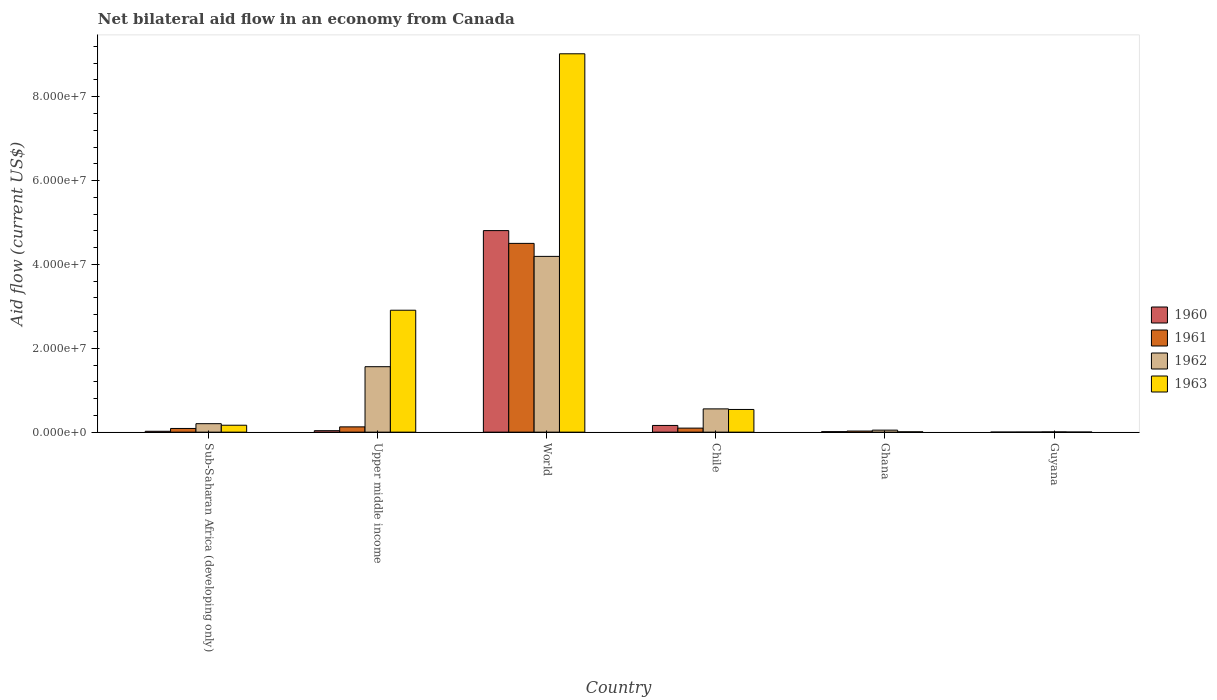How many different coloured bars are there?
Keep it short and to the point. 4. How many groups of bars are there?
Keep it short and to the point. 6. How many bars are there on the 5th tick from the right?
Your response must be concise. 4. What is the label of the 1st group of bars from the left?
Provide a short and direct response. Sub-Saharan Africa (developing only). What is the net bilateral aid flow in 1962 in World?
Offer a very short reply. 4.19e+07. Across all countries, what is the maximum net bilateral aid flow in 1962?
Your response must be concise. 4.19e+07. In which country was the net bilateral aid flow in 1963 maximum?
Give a very brief answer. World. In which country was the net bilateral aid flow in 1963 minimum?
Give a very brief answer. Guyana. What is the total net bilateral aid flow in 1962 in the graph?
Give a very brief answer. 6.56e+07. What is the difference between the net bilateral aid flow in 1960 in Chile and that in World?
Provide a succinct answer. -4.65e+07. What is the difference between the net bilateral aid flow in 1962 in Ghana and the net bilateral aid flow in 1960 in Upper middle income?
Offer a terse response. 1.30e+05. What is the average net bilateral aid flow in 1961 per country?
Your answer should be compact. 8.07e+06. What is the difference between the net bilateral aid flow of/in 1962 and net bilateral aid flow of/in 1963 in Upper middle income?
Your response must be concise. -1.35e+07. In how many countries, is the net bilateral aid flow in 1961 greater than 64000000 US$?
Offer a terse response. 0. What is the ratio of the net bilateral aid flow in 1963 in Ghana to that in Sub-Saharan Africa (developing only)?
Offer a very short reply. 0.05. What is the difference between the highest and the second highest net bilateral aid flow in 1962?
Provide a short and direct response. 2.63e+07. What is the difference between the highest and the lowest net bilateral aid flow in 1960?
Your answer should be compact. 4.81e+07. In how many countries, is the net bilateral aid flow in 1962 greater than the average net bilateral aid flow in 1962 taken over all countries?
Offer a terse response. 2. Is the sum of the net bilateral aid flow in 1963 in Sub-Saharan Africa (developing only) and Upper middle income greater than the maximum net bilateral aid flow in 1960 across all countries?
Give a very brief answer. No. Is it the case that in every country, the sum of the net bilateral aid flow in 1960 and net bilateral aid flow in 1961 is greater than the sum of net bilateral aid flow in 1962 and net bilateral aid flow in 1963?
Provide a succinct answer. No. How many bars are there?
Your answer should be compact. 24. How many countries are there in the graph?
Your answer should be compact. 6. Are the values on the major ticks of Y-axis written in scientific E-notation?
Your response must be concise. Yes. Does the graph contain any zero values?
Provide a succinct answer. No. Does the graph contain grids?
Provide a succinct answer. No. Where does the legend appear in the graph?
Your answer should be compact. Center right. How many legend labels are there?
Provide a succinct answer. 4. How are the legend labels stacked?
Give a very brief answer. Vertical. What is the title of the graph?
Make the answer very short. Net bilateral aid flow in an economy from Canada. What is the label or title of the X-axis?
Offer a terse response. Country. What is the label or title of the Y-axis?
Your response must be concise. Aid flow (current US$). What is the Aid flow (current US$) of 1961 in Sub-Saharan Africa (developing only)?
Provide a short and direct response. 8.80e+05. What is the Aid flow (current US$) of 1962 in Sub-Saharan Africa (developing only)?
Offer a terse response. 2.02e+06. What is the Aid flow (current US$) of 1963 in Sub-Saharan Africa (developing only)?
Keep it short and to the point. 1.65e+06. What is the Aid flow (current US$) of 1961 in Upper middle income?
Keep it short and to the point. 1.26e+06. What is the Aid flow (current US$) of 1962 in Upper middle income?
Provide a succinct answer. 1.56e+07. What is the Aid flow (current US$) in 1963 in Upper middle income?
Make the answer very short. 2.91e+07. What is the Aid flow (current US$) in 1960 in World?
Your answer should be compact. 4.81e+07. What is the Aid flow (current US$) of 1961 in World?
Your answer should be compact. 4.50e+07. What is the Aid flow (current US$) in 1962 in World?
Offer a very short reply. 4.19e+07. What is the Aid flow (current US$) in 1963 in World?
Make the answer very short. 9.02e+07. What is the Aid flow (current US$) of 1960 in Chile?
Provide a short and direct response. 1.60e+06. What is the Aid flow (current US$) of 1961 in Chile?
Your answer should be very brief. 9.60e+05. What is the Aid flow (current US$) of 1962 in Chile?
Offer a terse response. 5.55e+06. What is the Aid flow (current US$) of 1963 in Chile?
Ensure brevity in your answer.  5.41e+06. What is the Aid flow (current US$) in 1960 in Ghana?
Your answer should be compact. 1.20e+05. What is the Aid flow (current US$) of 1961 in Ghana?
Give a very brief answer. 2.60e+05. What is the Aid flow (current US$) of 1962 in Ghana?
Give a very brief answer. 4.80e+05. What is the Aid flow (current US$) of 1961 in Guyana?
Provide a short and direct response. 2.00e+04. Across all countries, what is the maximum Aid flow (current US$) in 1960?
Offer a terse response. 4.81e+07. Across all countries, what is the maximum Aid flow (current US$) of 1961?
Ensure brevity in your answer.  4.50e+07. Across all countries, what is the maximum Aid flow (current US$) of 1962?
Provide a short and direct response. 4.19e+07. Across all countries, what is the maximum Aid flow (current US$) in 1963?
Your response must be concise. 9.02e+07. Across all countries, what is the minimum Aid flow (current US$) in 1960?
Offer a very short reply. 10000. Across all countries, what is the minimum Aid flow (current US$) in 1961?
Give a very brief answer. 2.00e+04. Across all countries, what is the minimum Aid flow (current US$) in 1962?
Provide a short and direct response. 6.00e+04. Across all countries, what is the minimum Aid flow (current US$) in 1963?
Provide a short and direct response. 2.00e+04. What is the total Aid flow (current US$) of 1960 in the graph?
Your answer should be very brief. 5.04e+07. What is the total Aid flow (current US$) in 1961 in the graph?
Give a very brief answer. 4.84e+07. What is the total Aid flow (current US$) in 1962 in the graph?
Your answer should be very brief. 6.56e+07. What is the total Aid flow (current US$) of 1963 in the graph?
Give a very brief answer. 1.26e+08. What is the difference between the Aid flow (current US$) of 1961 in Sub-Saharan Africa (developing only) and that in Upper middle income?
Your answer should be very brief. -3.80e+05. What is the difference between the Aid flow (current US$) in 1962 in Sub-Saharan Africa (developing only) and that in Upper middle income?
Your response must be concise. -1.36e+07. What is the difference between the Aid flow (current US$) of 1963 in Sub-Saharan Africa (developing only) and that in Upper middle income?
Offer a very short reply. -2.74e+07. What is the difference between the Aid flow (current US$) in 1960 in Sub-Saharan Africa (developing only) and that in World?
Make the answer very short. -4.79e+07. What is the difference between the Aid flow (current US$) in 1961 in Sub-Saharan Africa (developing only) and that in World?
Offer a very short reply. -4.41e+07. What is the difference between the Aid flow (current US$) of 1962 in Sub-Saharan Africa (developing only) and that in World?
Your answer should be compact. -3.99e+07. What is the difference between the Aid flow (current US$) in 1963 in Sub-Saharan Africa (developing only) and that in World?
Offer a terse response. -8.86e+07. What is the difference between the Aid flow (current US$) of 1960 in Sub-Saharan Africa (developing only) and that in Chile?
Your answer should be very brief. -1.39e+06. What is the difference between the Aid flow (current US$) in 1962 in Sub-Saharan Africa (developing only) and that in Chile?
Your answer should be compact. -3.53e+06. What is the difference between the Aid flow (current US$) of 1963 in Sub-Saharan Africa (developing only) and that in Chile?
Provide a short and direct response. -3.76e+06. What is the difference between the Aid flow (current US$) in 1961 in Sub-Saharan Africa (developing only) and that in Ghana?
Ensure brevity in your answer.  6.20e+05. What is the difference between the Aid flow (current US$) of 1962 in Sub-Saharan Africa (developing only) and that in Ghana?
Offer a very short reply. 1.54e+06. What is the difference between the Aid flow (current US$) of 1963 in Sub-Saharan Africa (developing only) and that in Ghana?
Give a very brief answer. 1.57e+06. What is the difference between the Aid flow (current US$) in 1961 in Sub-Saharan Africa (developing only) and that in Guyana?
Your answer should be compact. 8.60e+05. What is the difference between the Aid flow (current US$) in 1962 in Sub-Saharan Africa (developing only) and that in Guyana?
Give a very brief answer. 1.96e+06. What is the difference between the Aid flow (current US$) of 1963 in Sub-Saharan Africa (developing only) and that in Guyana?
Keep it short and to the point. 1.63e+06. What is the difference between the Aid flow (current US$) in 1960 in Upper middle income and that in World?
Give a very brief answer. -4.77e+07. What is the difference between the Aid flow (current US$) in 1961 in Upper middle income and that in World?
Provide a short and direct response. -4.38e+07. What is the difference between the Aid flow (current US$) of 1962 in Upper middle income and that in World?
Provide a short and direct response. -2.63e+07. What is the difference between the Aid flow (current US$) of 1963 in Upper middle income and that in World?
Your answer should be very brief. -6.12e+07. What is the difference between the Aid flow (current US$) of 1960 in Upper middle income and that in Chile?
Your answer should be very brief. -1.25e+06. What is the difference between the Aid flow (current US$) of 1962 in Upper middle income and that in Chile?
Provide a succinct answer. 1.01e+07. What is the difference between the Aid flow (current US$) in 1963 in Upper middle income and that in Chile?
Provide a short and direct response. 2.37e+07. What is the difference between the Aid flow (current US$) in 1961 in Upper middle income and that in Ghana?
Your answer should be compact. 1.00e+06. What is the difference between the Aid flow (current US$) of 1962 in Upper middle income and that in Ghana?
Give a very brief answer. 1.51e+07. What is the difference between the Aid flow (current US$) of 1963 in Upper middle income and that in Ghana?
Make the answer very short. 2.90e+07. What is the difference between the Aid flow (current US$) in 1961 in Upper middle income and that in Guyana?
Your answer should be compact. 1.24e+06. What is the difference between the Aid flow (current US$) of 1962 in Upper middle income and that in Guyana?
Your response must be concise. 1.56e+07. What is the difference between the Aid flow (current US$) of 1963 in Upper middle income and that in Guyana?
Offer a terse response. 2.91e+07. What is the difference between the Aid flow (current US$) in 1960 in World and that in Chile?
Provide a succinct answer. 4.65e+07. What is the difference between the Aid flow (current US$) in 1961 in World and that in Chile?
Ensure brevity in your answer.  4.41e+07. What is the difference between the Aid flow (current US$) of 1962 in World and that in Chile?
Provide a short and direct response. 3.64e+07. What is the difference between the Aid flow (current US$) in 1963 in World and that in Chile?
Ensure brevity in your answer.  8.48e+07. What is the difference between the Aid flow (current US$) of 1960 in World and that in Ghana?
Make the answer very short. 4.80e+07. What is the difference between the Aid flow (current US$) in 1961 in World and that in Ghana?
Your response must be concise. 4.48e+07. What is the difference between the Aid flow (current US$) of 1962 in World and that in Ghana?
Your response must be concise. 4.14e+07. What is the difference between the Aid flow (current US$) in 1963 in World and that in Ghana?
Your answer should be very brief. 9.02e+07. What is the difference between the Aid flow (current US$) of 1960 in World and that in Guyana?
Make the answer very short. 4.81e+07. What is the difference between the Aid flow (current US$) of 1961 in World and that in Guyana?
Ensure brevity in your answer.  4.50e+07. What is the difference between the Aid flow (current US$) of 1962 in World and that in Guyana?
Your response must be concise. 4.19e+07. What is the difference between the Aid flow (current US$) of 1963 in World and that in Guyana?
Keep it short and to the point. 9.02e+07. What is the difference between the Aid flow (current US$) in 1960 in Chile and that in Ghana?
Offer a terse response. 1.48e+06. What is the difference between the Aid flow (current US$) of 1961 in Chile and that in Ghana?
Keep it short and to the point. 7.00e+05. What is the difference between the Aid flow (current US$) of 1962 in Chile and that in Ghana?
Make the answer very short. 5.07e+06. What is the difference between the Aid flow (current US$) in 1963 in Chile and that in Ghana?
Your response must be concise. 5.33e+06. What is the difference between the Aid flow (current US$) in 1960 in Chile and that in Guyana?
Offer a terse response. 1.59e+06. What is the difference between the Aid flow (current US$) of 1961 in Chile and that in Guyana?
Offer a very short reply. 9.40e+05. What is the difference between the Aid flow (current US$) of 1962 in Chile and that in Guyana?
Offer a very short reply. 5.49e+06. What is the difference between the Aid flow (current US$) in 1963 in Chile and that in Guyana?
Offer a very short reply. 5.39e+06. What is the difference between the Aid flow (current US$) of 1960 in Ghana and that in Guyana?
Offer a terse response. 1.10e+05. What is the difference between the Aid flow (current US$) of 1961 in Ghana and that in Guyana?
Ensure brevity in your answer.  2.40e+05. What is the difference between the Aid flow (current US$) in 1962 in Ghana and that in Guyana?
Offer a terse response. 4.20e+05. What is the difference between the Aid flow (current US$) in 1960 in Sub-Saharan Africa (developing only) and the Aid flow (current US$) in 1961 in Upper middle income?
Keep it short and to the point. -1.05e+06. What is the difference between the Aid flow (current US$) of 1960 in Sub-Saharan Africa (developing only) and the Aid flow (current US$) of 1962 in Upper middle income?
Offer a very short reply. -1.54e+07. What is the difference between the Aid flow (current US$) in 1960 in Sub-Saharan Africa (developing only) and the Aid flow (current US$) in 1963 in Upper middle income?
Offer a terse response. -2.89e+07. What is the difference between the Aid flow (current US$) of 1961 in Sub-Saharan Africa (developing only) and the Aid flow (current US$) of 1962 in Upper middle income?
Your response must be concise. -1.47e+07. What is the difference between the Aid flow (current US$) in 1961 in Sub-Saharan Africa (developing only) and the Aid flow (current US$) in 1963 in Upper middle income?
Your response must be concise. -2.82e+07. What is the difference between the Aid flow (current US$) in 1962 in Sub-Saharan Africa (developing only) and the Aid flow (current US$) in 1963 in Upper middle income?
Give a very brief answer. -2.71e+07. What is the difference between the Aid flow (current US$) of 1960 in Sub-Saharan Africa (developing only) and the Aid flow (current US$) of 1961 in World?
Provide a short and direct response. -4.48e+07. What is the difference between the Aid flow (current US$) in 1960 in Sub-Saharan Africa (developing only) and the Aid flow (current US$) in 1962 in World?
Make the answer very short. -4.17e+07. What is the difference between the Aid flow (current US$) of 1960 in Sub-Saharan Africa (developing only) and the Aid flow (current US$) of 1963 in World?
Your answer should be compact. -9.00e+07. What is the difference between the Aid flow (current US$) of 1961 in Sub-Saharan Africa (developing only) and the Aid flow (current US$) of 1962 in World?
Provide a succinct answer. -4.10e+07. What is the difference between the Aid flow (current US$) in 1961 in Sub-Saharan Africa (developing only) and the Aid flow (current US$) in 1963 in World?
Offer a terse response. -8.94e+07. What is the difference between the Aid flow (current US$) of 1962 in Sub-Saharan Africa (developing only) and the Aid flow (current US$) of 1963 in World?
Your answer should be very brief. -8.82e+07. What is the difference between the Aid flow (current US$) in 1960 in Sub-Saharan Africa (developing only) and the Aid flow (current US$) in 1961 in Chile?
Offer a very short reply. -7.50e+05. What is the difference between the Aid flow (current US$) in 1960 in Sub-Saharan Africa (developing only) and the Aid flow (current US$) in 1962 in Chile?
Make the answer very short. -5.34e+06. What is the difference between the Aid flow (current US$) of 1960 in Sub-Saharan Africa (developing only) and the Aid flow (current US$) of 1963 in Chile?
Provide a succinct answer. -5.20e+06. What is the difference between the Aid flow (current US$) of 1961 in Sub-Saharan Africa (developing only) and the Aid flow (current US$) of 1962 in Chile?
Provide a succinct answer. -4.67e+06. What is the difference between the Aid flow (current US$) in 1961 in Sub-Saharan Africa (developing only) and the Aid flow (current US$) in 1963 in Chile?
Offer a very short reply. -4.53e+06. What is the difference between the Aid flow (current US$) in 1962 in Sub-Saharan Africa (developing only) and the Aid flow (current US$) in 1963 in Chile?
Make the answer very short. -3.39e+06. What is the difference between the Aid flow (current US$) in 1960 in Sub-Saharan Africa (developing only) and the Aid flow (current US$) in 1961 in Ghana?
Keep it short and to the point. -5.00e+04. What is the difference between the Aid flow (current US$) in 1960 in Sub-Saharan Africa (developing only) and the Aid flow (current US$) in 1962 in Ghana?
Your answer should be compact. -2.70e+05. What is the difference between the Aid flow (current US$) of 1961 in Sub-Saharan Africa (developing only) and the Aid flow (current US$) of 1962 in Ghana?
Keep it short and to the point. 4.00e+05. What is the difference between the Aid flow (current US$) in 1961 in Sub-Saharan Africa (developing only) and the Aid flow (current US$) in 1963 in Ghana?
Provide a succinct answer. 8.00e+05. What is the difference between the Aid flow (current US$) of 1962 in Sub-Saharan Africa (developing only) and the Aid flow (current US$) of 1963 in Ghana?
Make the answer very short. 1.94e+06. What is the difference between the Aid flow (current US$) in 1960 in Sub-Saharan Africa (developing only) and the Aid flow (current US$) in 1962 in Guyana?
Offer a terse response. 1.50e+05. What is the difference between the Aid flow (current US$) in 1961 in Sub-Saharan Africa (developing only) and the Aid flow (current US$) in 1962 in Guyana?
Keep it short and to the point. 8.20e+05. What is the difference between the Aid flow (current US$) in 1961 in Sub-Saharan Africa (developing only) and the Aid flow (current US$) in 1963 in Guyana?
Provide a short and direct response. 8.60e+05. What is the difference between the Aid flow (current US$) of 1960 in Upper middle income and the Aid flow (current US$) of 1961 in World?
Your response must be concise. -4.47e+07. What is the difference between the Aid flow (current US$) in 1960 in Upper middle income and the Aid flow (current US$) in 1962 in World?
Offer a very short reply. -4.16e+07. What is the difference between the Aid flow (current US$) of 1960 in Upper middle income and the Aid flow (current US$) of 1963 in World?
Your response must be concise. -8.99e+07. What is the difference between the Aid flow (current US$) of 1961 in Upper middle income and the Aid flow (current US$) of 1962 in World?
Make the answer very short. -4.07e+07. What is the difference between the Aid flow (current US$) in 1961 in Upper middle income and the Aid flow (current US$) in 1963 in World?
Ensure brevity in your answer.  -8.90e+07. What is the difference between the Aid flow (current US$) of 1962 in Upper middle income and the Aid flow (current US$) of 1963 in World?
Offer a terse response. -7.46e+07. What is the difference between the Aid flow (current US$) in 1960 in Upper middle income and the Aid flow (current US$) in 1961 in Chile?
Your answer should be compact. -6.10e+05. What is the difference between the Aid flow (current US$) of 1960 in Upper middle income and the Aid flow (current US$) of 1962 in Chile?
Your response must be concise. -5.20e+06. What is the difference between the Aid flow (current US$) in 1960 in Upper middle income and the Aid flow (current US$) in 1963 in Chile?
Provide a succinct answer. -5.06e+06. What is the difference between the Aid flow (current US$) in 1961 in Upper middle income and the Aid flow (current US$) in 1962 in Chile?
Provide a short and direct response. -4.29e+06. What is the difference between the Aid flow (current US$) of 1961 in Upper middle income and the Aid flow (current US$) of 1963 in Chile?
Offer a very short reply. -4.15e+06. What is the difference between the Aid flow (current US$) in 1962 in Upper middle income and the Aid flow (current US$) in 1963 in Chile?
Offer a very short reply. 1.02e+07. What is the difference between the Aid flow (current US$) in 1960 in Upper middle income and the Aid flow (current US$) in 1961 in Ghana?
Keep it short and to the point. 9.00e+04. What is the difference between the Aid flow (current US$) of 1960 in Upper middle income and the Aid flow (current US$) of 1962 in Ghana?
Offer a very short reply. -1.30e+05. What is the difference between the Aid flow (current US$) of 1961 in Upper middle income and the Aid flow (current US$) of 1962 in Ghana?
Offer a very short reply. 7.80e+05. What is the difference between the Aid flow (current US$) of 1961 in Upper middle income and the Aid flow (current US$) of 1963 in Ghana?
Your response must be concise. 1.18e+06. What is the difference between the Aid flow (current US$) in 1962 in Upper middle income and the Aid flow (current US$) in 1963 in Ghana?
Your answer should be compact. 1.55e+07. What is the difference between the Aid flow (current US$) in 1960 in Upper middle income and the Aid flow (current US$) in 1962 in Guyana?
Ensure brevity in your answer.  2.90e+05. What is the difference between the Aid flow (current US$) of 1960 in Upper middle income and the Aid flow (current US$) of 1963 in Guyana?
Your response must be concise. 3.30e+05. What is the difference between the Aid flow (current US$) in 1961 in Upper middle income and the Aid flow (current US$) in 1962 in Guyana?
Your answer should be compact. 1.20e+06. What is the difference between the Aid flow (current US$) in 1961 in Upper middle income and the Aid flow (current US$) in 1963 in Guyana?
Your response must be concise. 1.24e+06. What is the difference between the Aid flow (current US$) of 1962 in Upper middle income and the Aid flow (current US$) of 1963 in Guyana?
Your response must be concise. 1.56e+07. What is the difference between the Aid flow (current US$) in 1960 in World and the Aid flow (current US$) in 1961 in Chile?
Make the answer very short. 4.71e+07. What is the difference between the Aid flow (current US$) of 1960 in World and the Aid flow (current US$) of 1962 in Chile?
Make the answer very short. 4.25e+07. What is the difference between the Aid flow (current US$) of 1960 in World and the Aid flow (current US$) of 1963 in Chile?
Provide a succinct answer. 4.27e+07. What is the difference between the Aid flow (current US$) of 1961 in World and the Aid flow (current US$) of 1962 in Chile?
Your response must be concise. 3.95e+07. What is the difference between the Aid flow (current US$) of 1961 in World and the Aid flow (current US$) of 1963 in Chile?
Provide a short and direct response. 3.96e+07. What is the difference between the Aid flow (current US$) in 1962 in World and the Aid flow (current US$) in 1963 in Chile?
Offer a very short reply. 3.65e+07. What is the difference between the Aid flow (current US$) of 1960 in World and the Aid flow (current US$) of 1961 in Ghana?
Provide a short and direct response. 4.78e+07. What is the difference between the Aid flow (current US$) of 1960 in World and the Aid flow (current US$) of 1962 in Ghana?
Provide a succinct answer. 4.76e+07. What is the difference between the Aid flow (current US$) of 1960 in World and the Aid flow (current US$) of 1963 in Ghana?
Ensure brevity in your answer.  4.80e+07. What is the difference between the Aid flow (current US$) in 1961 in World and the Aid flow (current US$) in 1962 in Ghana?
Your answer should be compact. 4.45e+07. What is the difference between the Aid flow (current US$) in 1961 in World and the Aid flow (current US$) in 1963 in Ghana?
Your response must be concise. 4.49e+07. What is the difference between the Aid flow (current US$) of 1962 in World and the Aid flow (current US$) of 1963 in Ghana?
Keep it short and to the point. 4.18e+07. What is the difference between the Aid flow (current US$) in 1960 in World and the Aid flow (current US$) in 1961 in Guyana?
Make the answer very short. 4.80e+07. What is the difference between the Aid flow (current US$) of 1960 in World and the Aid flow (current US$) of 1962 in Guyana?
Ensure brevity in your answer.  4.80e+07. What is the difference between the Aid flow (current US$) in 1960 in World and the Aid flow (current US$) in 1963 in Guyana?
Ensure brevity in your answer.  4.80e+07. What is the difference between the Aid flow (current US$) of 1961 in World and the Aid flow (current US$) of 1962 in Guyana?
Offer a terse response. 4.50e+07. What is the difference between the Aid flow (current US$) in 1961 in World and the Aid flow (current US$) in 1963 in Guyana?
Offer a terse response. 4.50e+07. What is the difference between the Aid flow (current US$) of 1962 in World and the Aid flow (current US$) of 1963 in Guyana?
Offer a very short reply. 4.19e+07. What is the difference between the Aid flow (current US$) of 1960 in Chile and the Aid flow (current US$) of 1961 in Ghana?
Your answer should be compact. 1.34e+06. What is the difference between the Aid flow (current US$) in 1960 in Chile and the Aid flow (current US$) in 1962 in Ghana?
Your answer should be very brief. 1.12e+06. What is the difference between the Aid flow (current US$) of 1960 in Chile and the Aid flow (current US$) of 1963 in Ghana?
Offer a terse response. 1.52e+06. What is the difference between the Aid flow (current US$) of 1961 in Chile and the Aid flow (current US$) of 1962 in Ghana?
Make the answer very short. 4.80e+05. What is the difference between the Aid flow (current US$) in 1961 in Chile and the Aid flow (current US$) in 1963 in Ghana?
Offer a terse response. 8.80e+05. What is the difference between the Aid flow (current US$) of 1962 in Chile and the Aid flow (current US$) of 1963 in Ghana?
Keep it short and to the point. 5.47e+06. What is the difference between the Aid flow (current US$) in 1960 in Chile and the Aid flow (current US$) in 1961 in Guyana?
Your answer should be compact. 1.58e+06. What is the difference between the Aid flow (current US$) of 1960 in Chile and the Aid flow (current US$) of 1962 in Guyana?
Give a very brief answer. 1.54e+06. What is the difference between the Aid flow (current US$) in 1960 in Chile and the Aid flow (current US$) in 1963 in Guyana?
Make the answer very short. 1.58e+06. What is the difference between the Aid flow (current US$) of 1961 in Chile and the Aid flow (current US$) of 1962 in Guyana?
Offer a very short reply. 9.00e+05. What is the difference between the Aid flow (current US$) of 1961 in Chile and the Aid flow (current US$) of 1963 in Guyana?
Provide a short and direct response. 9.40e+05. What is the difference between the Aid flow (current US$) in 1962 in Chile and the Aid flow (current US$) in 1963 in Guyana?
Ensure brevity in your answer.  5.53e+06. What is the difference between the Aid flow (current US$) in 1960 in Ghana and the Aid flow (current US$) in 1961 in Guyana?
Your answer should be very brief. 1.00e+05. What is the difference between the Aid flow (current US$) of 1961 in Ghana and the Aid flow (current US$) of 1962 in Guyana?
Provide a short and direct response. 2.00e+05. What is the average Aid flow (current US$) of 1960 per country?
Your response must be concise. 8.39e+06. What is the average Aid flow (current US$) of 1961 per country?
Your response must be concise. 8.07e+06. What is the average Aid flow (current US$) in 1962 per country?
Ensure brevity in your answer.  1.09e+07. What is the average Aid flow (current US$) in 1963 per country?
Give a very brief answer. 2.11e+07. What is the difference between the Aid flow (current US$) of 1960 and Aid flow (current US$) of 1961 in Sub-Saharan Africa (developing only)?
Provide a succinct answer. -6.70e+05. What is the difference between the Aid flow (current US$) in 1960 and Aid flow (current US$) in 1962 in Sub-Saharan Africa (developing only)?
Offer a terse response. -1.81e+06. What is the difference between the Aid flow (current US$) of 1960 and Aid flow (current US$) of 1963 in Sub-Saharan Africa (developing only)?
Offer a terse response. -1.44e+06. What is the difference between the Aid flow (current US$) in 1961 and Aid flow (current US$) in 1962 in Sub-Saharan Africa (developing only)?
Give a very brief answer. -1.14e+06. What is the difference between the Aid flow (current US$) of 1961 and Aid flow (current US$) of 1963 in Sub-Saharan Africa (developing only)?
Offer a very short reply. -7.70e+05. What is the difference between the Aid flow (current US$) of 1962 and Aid flow (current US$) of 1963 in Sub-Saharan Africa (developing only)?
Your answer should be compact. 3.70e+05. What is the difference between the Aid flow (current US$) of 1960 and Aid flow (current US$) of 1961 in Upper middle income?
Keep it short and to the point. -9.10e+05. What is the difference between the Aid flow (current US$) in 1960 and Aid flow (current US$) in 1962 in Upper middle income?
Your response must be concise. -1.53e+07. What is the difference between the Aid flow (current US$) in 1960 and Aid flow (current US$) in 1963 in Upper middle income?
Keep it short and to the point. -2.87e+07. What is the difference between the Aid flow (current US$) of 1961 and Aid flow (current US$) of 1962 in Upper middle income?
Offer a very short reply. -1.44e+07. What is the difference between the Aid flow (current US$) in 1961 and Aid flow (current US$) in 1963 in Upper middle income?
Give a very brief answer. -2.78e+07. What is the difference between the Aid flow (current US$) of 1962 and Aid flow (current US$) of 1963 in Upper middle income?
Make the answer very short. -1.35e+07. What is the difference between the Aid flow (current US$) of 1960 and Aid flow (current US$) of 1961 in World?
Your response must be concise. 3.05e+06. What is the difference between the Aid flow (current US$) of 1960 and Aid flow (current US$) of 1962 in World?
Provide a succinct answer. 6.15e+06. What is the difference between the Aid flow (current US$) of 1960 and Aid flow (current US$) of 1963 in World?
Provide a succinct answer. -4.22e+07. What is the difference between the Aid flow (current US$) of 1961 and Aid flow (current US$) of 1962 in World?
Provide a short and direct response. 3.10e+06. What is the difference between the Aid flow (current US$) of 1961 and Aid flow (current US$) of 1963 in World?
Offer a very short reply. -4.52e+07. What is the difference between the Aid flow (current US$) in 1962 and Aid flow (current US$) in 1963 in World?
Your answer should be very brief. -4.83e+07. What is the difference between the Aid flow (current US$) of 1960 and Aid flow (current US$) of 1961 in Chile?
Provide a succinct answer. 6.40e+05. What is the difference between the Aid flow (current US$) in 1960 and Aid flow (current US$) in 1962 in Chile?
Provide a succinct answer. -3.95e+06. What is the difference between the Aid flow (current US$) in 1960 and Aid flow (current US$) in 1963 in Chile?
Ensure brevity in your answer.  -3.81e+06. What is the difference between the Aid flow (current US$) in 1961 and Aid flow (current US$) in 1962 in Chile?
Offer a very short reply. -4.59e+06. What is the difference between the Aid flow (current US$) of 1961 and Aid flow (current US$) of 1963 in Chile?
Offer a terse response. -4.45e+06. What is the difference between the Aid flow (current US$) in 1960 and Aid flow (current US$) in 1961 in Ghana?
Your response must be concise. -1.40e+05. What is the difference between the Aid flow (current US$) in 1960 and Aid flow (current US$) in 1962 in Ghana?
Ensure brevity in your answer.  -3.60e+05. What is the difference between the Aid flow (current US$) of 1961 and Aid flow (current US$) of 1962 in Ghana?
Ensure brevity in your answer.  -2.20e+05. What is the difference between the Aid flow (current US$) of 1961 and Aid flow (current US$) of 1963 in Ghana?
Your answer should be very brief. 1.80e+05. What is the difference between the Aid flow (current US$) in 1962 and Aid flow (current US$) in 1963 in Ghana?
Offer a terse response. 4.00e+05. What is the difference between the Aid flow (current US$) of 1960 and Aid flow (current US$) of 1963 in Guyana?
Your answer should be compact. -10000. What is the difference between the Aid flow (current US$) in 1961 and Aid flow (current US$) in 1962 in Guyana?
Ensure brevity in your answer.  -4.00e+04. What is the difference between the Aid flow (current US$) in 1962 and Aid flow (current US$) in 1963 in Guyana?
Give a very brief answer. 4.00e+04. What is the ratio of the Aid flow (current US$) in 1961 in Sub-Saharan Africa (developing only) to that in Upper middle income?
Make the answer very short. 0.7. What is the ratio of the Aid flow (current US$) of 1962 in Sub-Saharan Africa (developing only) to that in Upper middle income?
Provide a succinct answer. 0.13. What is the ratio of the Aid flow (current US$) in 1963 in Sub-Saharan Africa (developing only) to that in Upper middle income?
Your answer should be compact. 0.06. What is the ratio of the Aid flow (current US$) in 1960 in Sub-Saharan Africa (developing only) to that in World?
Your response must be concise. 0. What is the ratio of the Aid flow (current US$) of 1961 in Sub-Saharan Africa (developing only) to that in World?
Your answer should be compact. 0.02. What is the ratio of the Aid flow (current US$) of 1962 in Sub-Saharan Africa (developing only) to that in World?
Give a very brief answer. 0.05. What is the ratio of the Aid flow (current US$) of 1963 in Sub-Saharan Africa (developing only) to that in World?
Your answer should be very brief. 0.02. What is the ratio of the Aid flow (current US$) in 1960 in Sub-Saharan Africa (developing only) to that in Chile?
Your answer should be very brief. 0.13. What is the ratio of the Aid flow (current US$) in 1962 in Sub-Saharan Africa (developing only) to that in Chile?
Offer a terse response. 0.36. What is the ratio of the Aid flow (current US$) of 1963 in Sub-Saharan Africa (developing only) to that in Chile?
Provide a succinct answer. 0.3. What is the ratio of the Aid flow (current US$) of 1961 in Sub-Saharan Africa (developing only) to that in Ghana?
Offer a very short reply. 3.38. What is the ratio of the Aid flow (current US$) of 1962 in Sub-Saharan Africa (developing only) to that in Ghana?
Provide a short and direct response. 4.21. What is the ratio of the Aid flow (current US$) of 1963 in Sub-Saharan Africa (developing only) to that in Ghana?
Your answer should be compact. 20.62. What is the ratio of the Aid flow (current US$) in 1961 in Sub-Saharan Africa (developing only) to that in Guyana?
Ensure brevity in your answer.  44. What is the ratio of the Aid flow (current US$) in 1962 in Sub-Saharan Africa (developing only) to that in Guyana?
Offer a very short reply. 33.67. What is the ratio of the Aid flow (current US$) of 1963 in Sub-Saharan Africa (developing only) to that in Guyana?
Ensure brevity in your answer.  82.5. What is the ratio of the Aid flow (current US$) in 1960 in Upper middle income to that in World?
Make the answer very short. 0.01. What is the ratio of the Aid flow (current US$) of 1961 in Upper middle income to that in World?
Provide a succinct answer. 0.03. What is the ratio of the Aid flow (current US$) of 1962 in Upper middle income to that in World?
Offer a very short reply. 0.37. What is the ratio of the Aid flow (current US$) in 1963 in Upper middle income to that in World?
Offer a terse response. 0.32. What is the ratio of the Aid flow (current US$) in 1960 in Upper middle income to that in Chile?
Your answer should be very brief. 0.22. What is the ratio of the Aid flow (current US$) in 1961 in Upper middle income to that in Chile?
Offer a terse response. 1.31. What is the ratio of the Aid flow (current US$) in 1962 in Upper middle income to that in Chile?
Make the answer very short. 2.81. What is the ratio of the Aid flow (current US$) in 1963 in Upper middle income to that in Chile?
Your answer should be very brief. 5.38. What is the ratio of the Aid flow (current US$) of 1960 in Upper middle income to that in Ghana?
Offer a very short reply. 2.92. What is the ratio of the Aid flow (current US$) of 1961 in Upper middle income to that in Ghana?
Give a very brief answer. 4.85. What is the ratio of the Aid flow (current US$) of 1962 in Upper middle income to that in Ghana?
Offer a very short reply. 32.52. What is the ratio of the Aid flow (current US$) of 1963 in Upper middle income to that in Ghana?
Give a very brief answer. 363.5. What is the ratio of the Aid flow (current US$) in 1960 in Upper middle income to that in Guyana?
Keep it short and to the point. 35. What is the ratio of the Aid flow (current US$) in 1962 in Upper middle income to that in Guyana?
Keep it short and to the point. 260.17. What is the ratio of the Aid flow (current US$) of 1963 in Upper middle income to that in Guyana?
Make the answer very short. 1454. What is the ratio of the Aid flow (current US$) of 1960 in World to that in Chile?
Your response must be concise. 30.04. What is the ratio of the Aid flow (current US$) in 1961 in World to that in Chile?
Your response must be concise. 46.9. What is the ratio of the Aid flow (current US$) of 1962 in World to that in Chile?
Ensure brevity in your answer.  7.55. What is the ratio of the Aid flow (current US$) in 1963 in World to that in Chile?
Your response must be concise. 16.68. What is the ratio of the Aid flow (current US$) of 1960 in World to that in Ghana?
Your response must be concise. 400.58. What is the ratio of the Aid flow (current US$) in 1961 in World to that in Ghana?
Your answer should be compact. 173.15. What is the ratio of the Aid flow (current US$) in 1962 in World to that in Ghana?
Give a very brief answer. 87.33. What is the ratio of the Aid flow (current US$) in 1963 in World to that in Ghana?
Your response must be concise. 1128. What is the ratio of the Aid flow (current US$) of 1960 in World to that in Guyana?
Give a very brief answer. 4807. What is the ratio of the Aid flow (current US$) of 1961 in World to that in Guyana?
Provide a succinct answer. 2251. What is the ratio of the Aid flow (current US$) in 1962 in World to that in Guyana?
Your answer should be very brief. 698.67. What is the ratio of the Aid flow (current US$) in 1963 in World to that in Guyana?
Give a very brief answer. 4512. What is the ratio of the Aid flow (current US$) in 1960 in Chile to that in Ghana?
Keep it short and to the point. 13.33. What is the ratio of the Aid flow (current US$) in 1961 in Chile to that in Ghana?
Ensure brevity in your answer.  3.69. What is the ratio of the Aid flow (current US$) of 1962 in Chile to that in Ghana?
Provide a short and direct response. 11.56. What is the ratio of the Aid flow (current US$) of 1963 in Chile to that in Ghana?
Give a very brief answer. 67.62. What is the ratio of the Aid flow (current US$) in 1960 in Chile to that in Guyana?
Offer a terse response. 160. What is the ratio of the Aid flow (current US$) in 1962 in Chile to that in Guyana?
Your answer should be very brief. 92.5. What is the ratio of the Aid flow (current US$) of 1963 in Chile to that in Guyana?
Your answer should be compact. 270.5. What is the ratio of the Aid flow (current US$) of 1961 in Ghana to that in Guyana?
Your response must be concise. 13. What is the difference between the highest and the second highest Aid flow (current US$) of 1960?
Offer a very short reply. 4.65e+07. What is the difference between the highest and the second highest Aid flow (current US$) in 1961?
Your answer should be very brief. 4.38e+07. What is the difference between the highest and the second highest Aid flow (current US$) in 1962?
Give a very brief answer. 2.63e+07. What is the difference between the highest and the second highest Aid flow (current US$) of 1963?
Offer a very short reply. 6.12e+07. What is the difference between the highest and the lowest Aid flow (current US$) in 1960?
Your answer should be compact. 4.81e+07. What is the difference between the highest and the lowest Aid flow (current US$) of 1961?
Keep it short and to the point. 4.50e+07. What is the difference between the highest and the lowest Aid flow (current US$) in 1962?
Offer a very short reply. 4.19e+07. What is the difference between the highest and the lowest Aid flow (current US$) in 1963?
Your answer should be compact. 9.02e+07. 